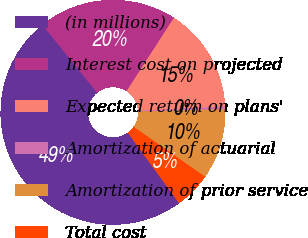Convert chart. <chart><loc_0><loc_0><loc_500><loc_500><pie_chart><fcel>(in millions)<fcel>Interest cost on projected<fcel>Expected return on plans'<fcel>Amortization of actuarial<fcel>Amortization of prior service<fcel>Total cost<nl><fcel>49.22%<fcel>19.92%<fcel>15.04%<fcel>0.39%<fcel>10.16%<fcel>5.27%<nl></chart> 